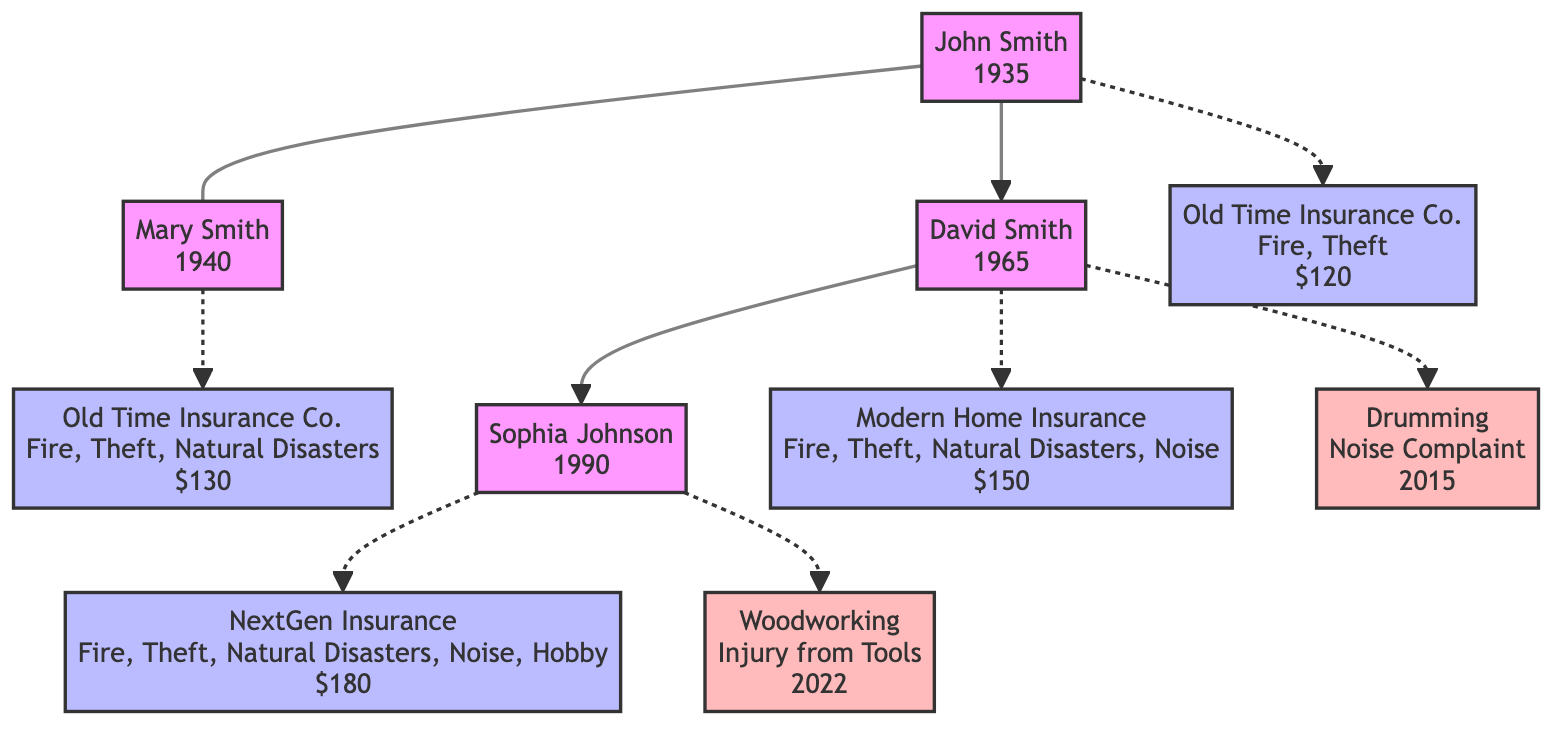What is the birth year of David Smith? The diagram shows that David Smith was born in 1965. We can find this information displayed next to his name in the family tree.
Answer: 1965 Who is the spouse of John Smith? The diagram indicates that Mary Smith is connected to John Smith with a relation labeled "spouse." The line connecting their nodes makes this relationship clear.
Answer: Mary Smith What is the premium for Sophia Johnson's home insurance policy? Looking at Sophia Johnson's node, her home insurance policy shows a premium of 180 as indicated in the box near her name.
Answer: 180 Which insurance provider covers noise disturbances for David Smith? The policy information next to David Smith's node states that "Modern Home Insurance" covers noise disturbances as part of his policy, as noted in the list of coverages.
Answer: Modern Home Insurance Which hobby-related incident involved David Smith? In the diagram, David Smith has a hobby-related incident described as "Noise Complaint" connected to his node, detailing the year it occurred as 2015.
Answer: Noise Complaint What is the relationship type between Sophia Johnson and David Smith? The diagram shows an arrow connecting Sophia Johnson to David Smith, labeled with the relation "child," clearly indicating that she is the child of David Smith.
Answer: child Which additional coverage does Sophia Johnson have compared to John Smith? The diagram highlights that Sophia Johnson's policy includes "Hobby-related Incidents," which is not present in John Smith's policy. We compare the coverage lists from their respective nodes to see this difference.
Answer: Hobby-related Incidents What year was David Smith enrolled in his home insurance policy? David Smith's node states that he was enrolled in his home insurance policy in 1990, as indicated in the information provided next to his name in the diagram.
Answer: 1990 Which family member had an incident related to woodworking? The diagram specifies that Sophia Johnson had a hobby-related incident labeled "Injury from Tools" as part of her woodworking activities, drawn from her node in the family tree.
Answer: Sophia Johnson 